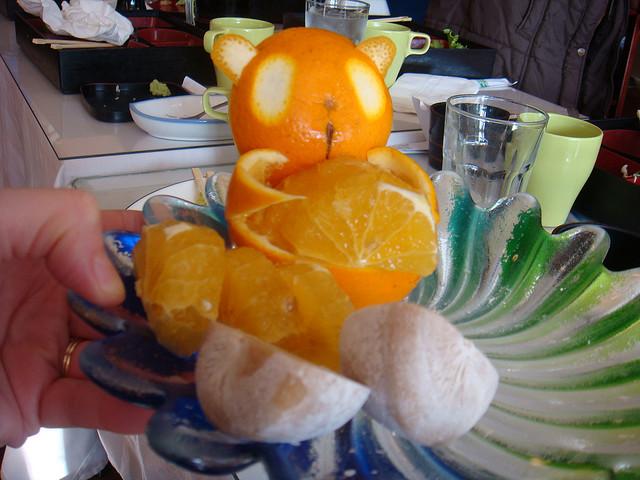What is the design of this arrangement?
Be succinct. Bear. Is the person holding the plate married?
Short answer required. Yes. What color is the orange?
Answer briefly. Orange. 